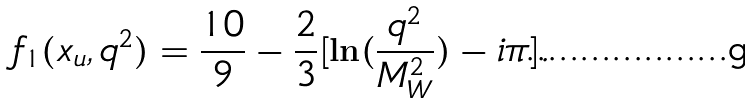<formula> <loc_0><loc_0><loc_500><loc_500>f _ { 1 } ( x _ { u } , q ^ { 2 } ) = \frac { 1 0 } { 9 } - \frac { 2 } { 3 } [ \ln ( \frac { q ^ { 2 } } { M _ { W } ^ { 2 } } ) - i \pi ] .</formula> 